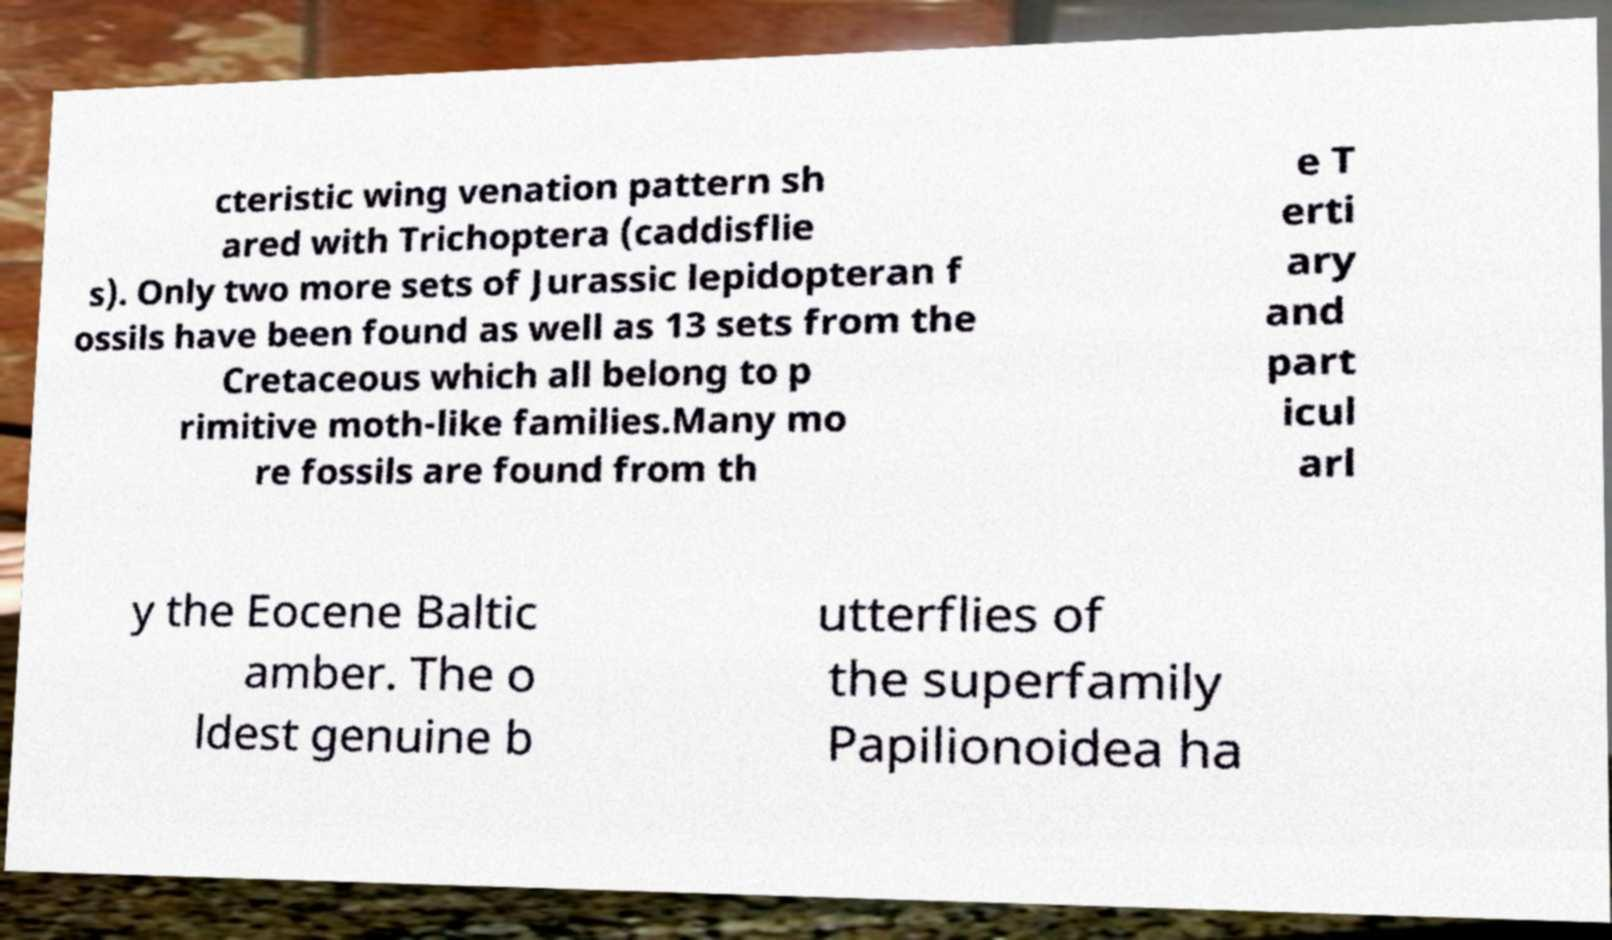Please identify and transcribe the text found in this image. cteristic wing venation pattern sh ared with Trichoptera (caddisflie s). Only two more sets of Jurassic lepidopteran f ossils have been found as well as 13 sets from the Cretaceous which all belong to p rimitive moth-like families.Many mo re fossils are found from th e T erti ary and part icul arl y the Eocene Baltic amber. The o ldest genuine b utterflies of the superfamily Papilionoidea ha 